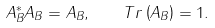Convert formula to latex. <formula><loc_0><loc_0><loc_500><loc_500>A _ { B } ^ { * } A _ { B } = A _ { B } , \quad T r \left ( A _ { B } \right ) = 1 .</formula> 